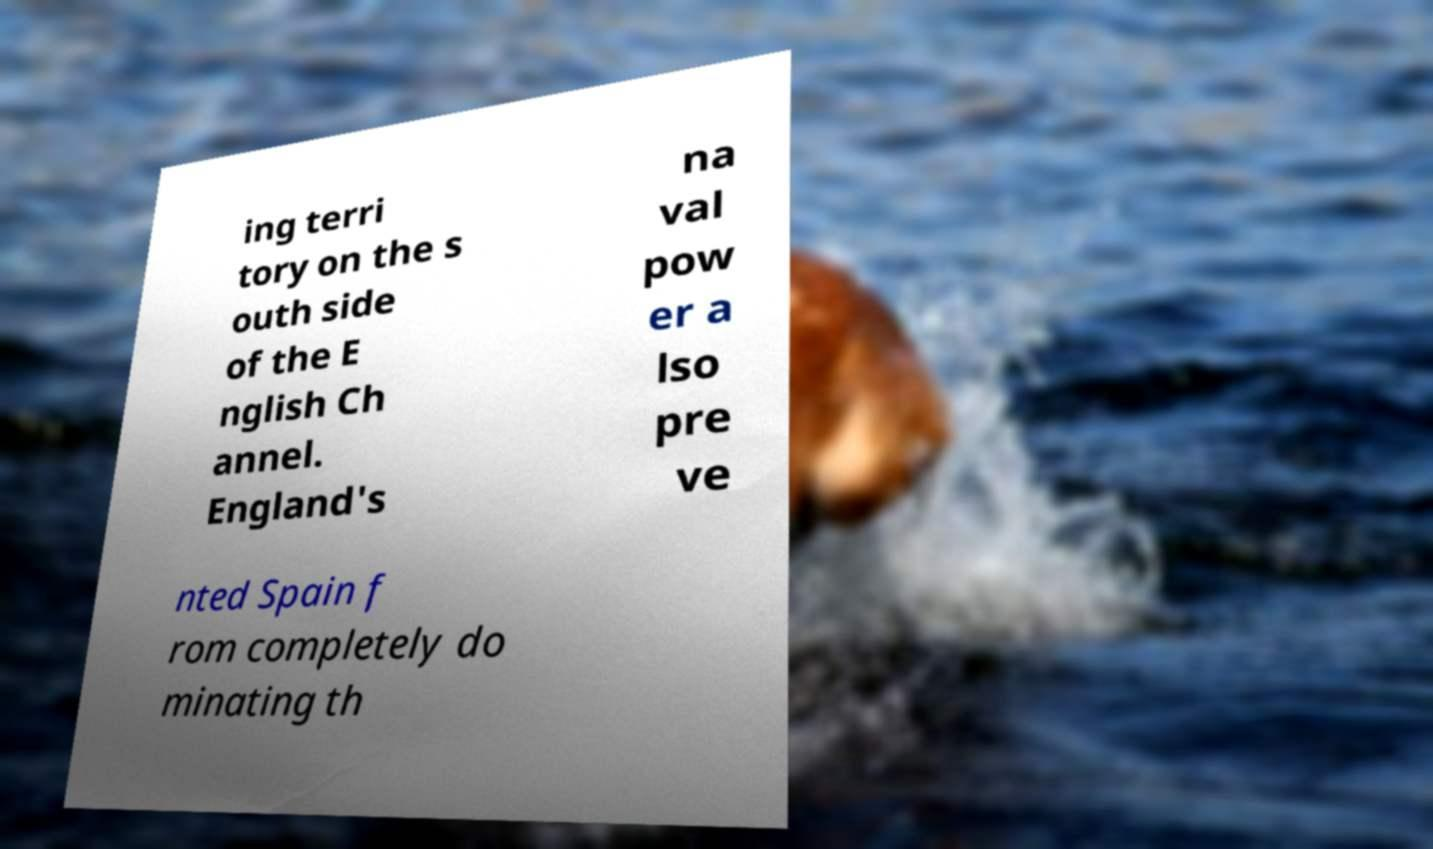Please read and relay the text visible in this image. What does it say? ing terri tory on the s outh side of the E nglish Ch annel. England's na val pow er a lso pre ve nted Spain f rom completely do minating th 